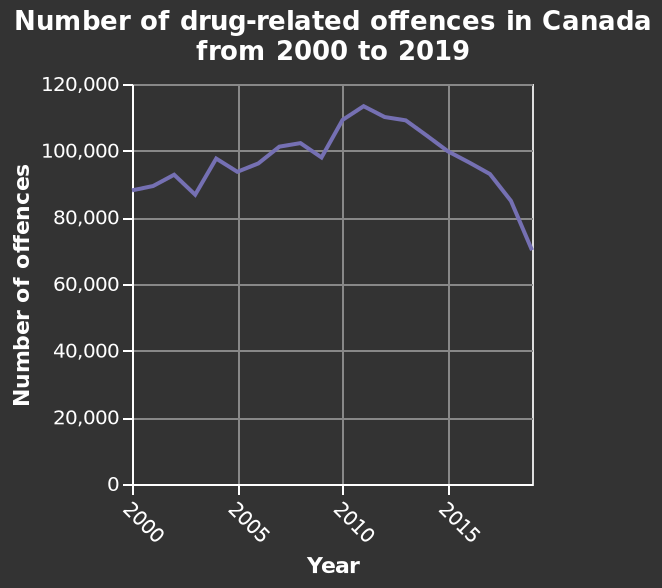<image>
What year had the highest number of drug-related offences in Canada?  The highest number of drug-related offences in Canada was in 2011. What is the current number of drug-related offences in Canada? In the current year, the number of drug-related offences is around 70,000. 